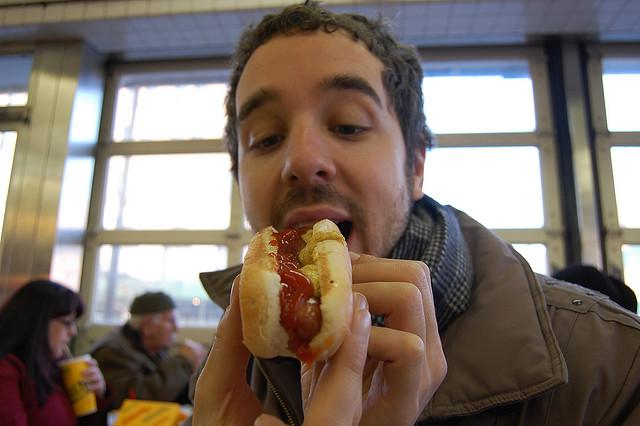What style of food is being served? Please explain your reasoning. american. The style is american. 